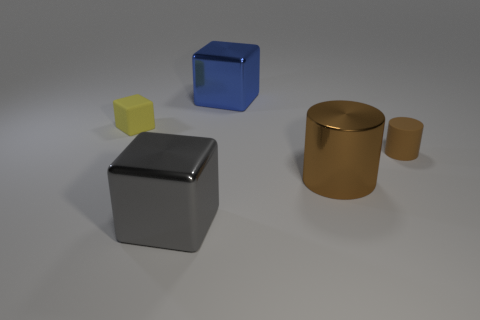How many other rubber cubes are the same color as the tiny matte block?
Offer a very short reply. 0. There is a metallic thing that is right of the large thing behind the brown rubber cylinder; what shape is it?
Your answer should be very brief. Cylinder. Is there a brown thing of the same shape as the gray thing?
Give a very brief answer. No. Is the color of the shiny cylinder the same as the rubber thing that is left of the large brown cylinder?
Give a very brief answer. No. There is a object that is the same color as the tiny cylinder; what is its size?
Give a very brief answer. Large. Are there any brown rubber things of the same size as the blue thing?
Keep it short and to the point. No. Do the blue object and the large thing left of the big blue metal block have the same material?
Provide a succinct answer. Yes. Are there more large objects than blue balls?
Ensure brevity in your answer.  Yes. How many cylinders are yellow rubber things or small things?
Provide a succinct answer. 1. What color is the metal cylinder?
Offer a terse response. Brown. 